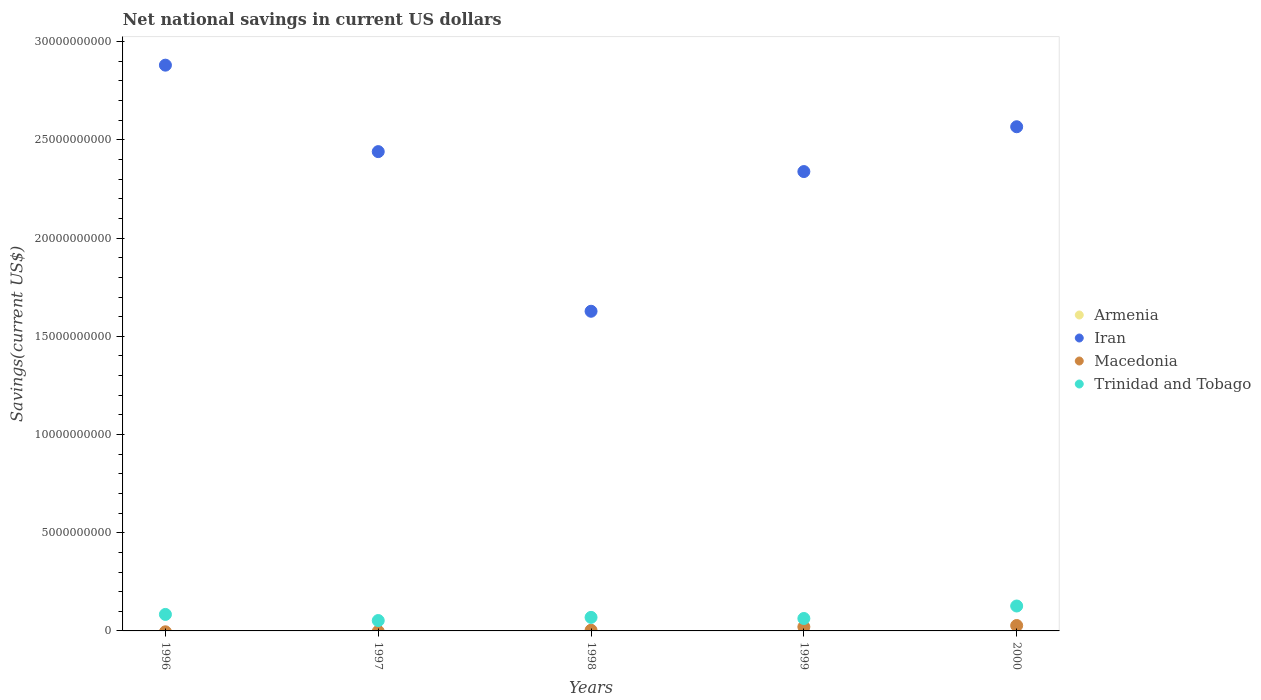How many different coloured dotlines are there?
Give a very brief answer. 3. What is the net national savings in Armenia in 1997?
Offer a terse response. 0. Across all years, what is the maximum net national savings in Trinidad and Tobago?
Your answer should be compact. 1.27e+09. Across all years, what is the minimum net national savings in Trinidad and Tobago?
Offer a terse response. 5.29e+08. What is the total net national savings in Macedonia in the graph?
Provide a succinct answer. 5.16e+08. What is the difference between the net national savings in Iran in 1997 and that in 1998?
Your answer should be very brief. 8.13e+09. What is the difference between the net national savings in Macedonia in 1998 and the net national savings in Iran in 2000?
Keep it short and to the point. -2.56e+1. What is the average net national savings in Macedonia per year?
Provide a short and direct response. 1.03e+08. In the year 2000, what is the difference between the net national savings in Iran and net national savings in Trinidad and Tobago?
Offer a very short reply. 2.44e+1. What is the ratio of the net national savings in Iran in 1996 to that in 2000?
Keep it short and to the point. 1.12. Is the net national savings in Iran in 1996 less than that in 2000?
Keep it short and to the point. No. Is the difference between the net national savings in Iran in 1996 and 1997 greater than the difference between the net national savings in Trinidad and Tobago in 1996 and 1997?
Provide a short and direct response. Yes. What is the difference between the highest and the second highest net national savings in Iran?
Offer a very short reply. 3.14e+09. What is the difference between the highest and the lowest net national savings in Trinidad and Tobago?
Provide a succinct answer. 7.40e+08. In how many years, is the net national savings in Macedonia greater than the average net national savings in Macedonia taken over all years?
Provide a short and direct response. 2. Is the sum of the net national savings in Trinidad and Tobago in 1999 and 2000 greater than the maximum net national savings in Iran across all years?
Give a very brief answer. No. How many years are there in the graph?
Keep it short and to the point. 5. What is the difference between two consecutive major ticks on the Y-axis?
Provide a succinct answer. 5.00e+09. Does the graph contain any zero values?
Your response must be concise. Yes. Does the graph contain grids?
Offer a terse response. No. Where does the legend appear in the graph?
Offer a very short reply. Center right. How are the legend labels stacked?
Keep it short and to the point. Vertical. What is the title of the graph?
Provide a succinct answer. Net national savings in current US dollars. What is the label or title of the Y-axis?
Provide a succinct answer. Savings(current US$). What is the Savings(current US$) of Armenia in 1996?
Your response must be concise. 0. What is the Savings(current US$) of Iran in 1996?
Your response must be concise. 2.88e+1. What is the Savings(current US$) in Macedonia in 1996?
Provide a short and direct response. 0. What is the Savings(current US$) in Trinidad and Tobago in 1996?
Your answer should be very brief. 8.40e+08. What is the Savings(current US$) of Armenia in 1997?
Your response must be concise. 0. What is the Savings(current US$) of Iran in 1997?
Give a very brief answer. 2.44e+1. What is the Savings(current US$) of Macedonia in 1997?
Offer a very short reply. 0. What is the Savings(current US$) in Trinidad and Tobago in 1997?
Provide a succinct answer. 5.29e+08. What is the Savings(current US$) in Armenia in 1998?
Offer a terse response. 0. What is the Savings(current US$) in Iran in 1998?
Give a very brief answer. 1.63e+1. What is the Savings(current US$) of Macedonia in 1998?
Give a very brief answer. 3.56e+07. What is the Savings(current US$) in Trinidad and Tobago in 1998?
Ensure brevity in your answer.  6.90e+08. What is the Savings(current US$) of Iran in 1999?
Make the answer very short. 2.34e+1. What is the Savings(current US$) in Macedonia in 1999?
Make the answer very short. 2.06e+08. What is the Savings(current US$) in Trinidad and Tobago in 1999?
Provide a short and direct response. 6.33e+08. What is the Savings(current US$) in Armenia in 2000?
Ensure brevity in your answer.  0. What is the Savings(current US$) in Iran in 2000?
Your answer should be very brief. 2.57e+1. What is the Savings(current US$) in Macedonia in 2000?
Provide a short and direct response. 2.75e+08. What is the Savings(current US$) of Trinidad and Tobago in 2000?
Keep it short and to the point. 1.27e+09. Across all years, what is the maximum Savings(current US$) of Iran?
Your response must be concise. 2.88e+1. Across all years, what is the maximum Savings(current US$) in Macedonia?
Your answer should be compact. 2.75e+08. Across all years, what is the maximum Savings(current US$) of Trinidad and Tobago?
Provide a short and direct response. 1.27e+09. Across all years, what is the minimum Savings(current US$) of Iran?
Keep it short and to the point. 1.63e+1. Across all years, what is the minimum Savings(current US$) of Macedonia?
Give a very brief answer. 0. Across all years, what is the minimum Savings(current US$) in Trinidad and Tobago?
Offer a very short reply. 5.29e+08. What is the total Savings(current US$) of Armenia in the graph?
Provide a succinct answer. 0. What is the total Savings(current US$) in Iran in the graph?
Provide a short and direct response. 1.19e+11. What is the total Savings(current US$) in Macedonia in the graph?
Ensure brevity in your answer.  5.16e+08. What is the total Savings(current US$) of Trinidad and Tobago in the graph?
Provide a succinct answer. 3.96e+09. What is the difference between the Savings(current US$) in Iran in 1996 and that in 1997?
Make the answer very short. 4.40e+09. What is the difference between the Savings(current US$) in Trinidad and Tobago in 1996 and that in 1997?
Give a very brief answer. 3.11e+08. What is the difference between the Savings(current US$) of Iran in 1996 and that in 1998?
Your answer should be very brief. 1.25e+1. What is the difference between the Savings(current US$) in Trinidad and Tobago in 1996 and that in 1998?
Give a very brief answer. 1.50e+08. What is the difference between the Savings(current US$) of Iran in 1996 and that in 1999?
Offer a terse response. 5.42e+09. What is the difference between the Savings(current US$) of Trinidad and Tobago in 1996 and that in 1999?
Your answer should be compact. 2.07e+08. What is the difference between the Savings(current US$) in Iran in 1996 and that in 2000?
Provide a succinct answer. 3.14e+09. What is the difference between the Savings(current US$) of Trinidad and Tobago in 1996 and that in 2000?
Your response must be concise. -4.29e+08. What is the difference between the Savings(current US$) in Iran in 1997 and that in 1998?
Provide a succinct answer. 8.13e+09. What is the difference between the Savings(current US$) of Trinidad and Tobago in 1997 and that in 1998?
Make the answer very short. -1.61e+08. What is the difference between the Savings(current US$) in Iran in 1997 and that in 1999?
Keep it short and to the point. 1.02e+09. What is the difference between the Savings(current US$) of Trinidad and Tobago in 1997 and that in 1999?
Your response must be concise. -1.05e+08. What is the difference between the Savings(current US$) in Iran in 1997 and that in 2000?
Offer a very short reply. -1.27e+09. What is the difference between the Savings(current US$) in Trinidad and Tobago in 1997 and that in 2000?
Your answer should be very brief. -7.40e+08. What is the difference between the Savings(current US$) of Iran in 1998 and that in 1999?
Ensure brevity in your answer.  -7.11e+09. What is the difference between the Savings(current US$) in Macedonia in 1998 and that in 1999?
Keep it short and to the point. -1.70e+08. What is the difference between the Savings(current US$) in Trinidad and Tobago in 1998 and that in 1999?
Give a very brief answer. 5.64e+07. What is the difference between the Savings(current US$) of Iran in 1998 and that in 2000?
Your response must be concise. -9.39e+09. What is the difference between the Savings(current US$) of Macedonia in 1998 and that in 2000?
Make the answer very short. -2.39e+08. What is the difference between the Savings(current US$) in Trinidad and Tobago in 1998 and that in 2000?
Offer a very short reply. -5.79e+08. What is the difference between the Savings(current US$) of Iran in 1999 and that in 2000?
Offer a terse response. -2.28e+09. What is the difference between the Savings(current US$) of Macedonia in 1999 and that in 2000?
Make the answer very short. -6.90e+07. What is the difference between the Savings(current US$) of Trinidad and Tobago in 1999 and that in 2000?
Keep it short and to the point. -6.36e+08. What is the difference between the Savings(current US$) in Iran in 1996 and the Savings(current US$) in Trinidad and Tobago in 1997?
Offer a terse response. 2.83e+1. What is the difference between the Savings(current US$) in Iran in 1996 and the Savings(current US$) in Macedonia in 1998?
Make the answer very short. 2.88e+1. What is the difference between the Savings(current US$) in Iran in 1996 and the Savings(current US$) in Trinidad and Tobago in 1998?
Ensure brevity in your answer.  2.81e+1. What is the difference between the Savings(current US$) of Iran in 1996 and the Savings(current US$) of Macedonia in 1999?
Give a very brief answer. 2.86e+1. What is the difference between the Savings(current US$) of Iran in 1996 and the Savings(current US$) of Trinidad and Tobago in 1999?
Your answer should be very brief. 2.82e+1. What is the difference between the Savings(current US$) of Iran in 1996 and the Savings(current US$) of Macedonia in 2000?
Provide a succinct answer. 2.85e+1. What is the difference between the Savings(current US$) of Iran in 1996 and the Savings(current US$) of Trinidad and Tobago in 2000?
Your answer should be very brief. 2.75e+1. What is the difference between the Savings(current US$) of Iran in 1997 and the Savings(current US$) of Macedonia in 1998?
Your answer should be very brief. 2.44e+1. What is the difference between the Savings(current US$) of Iran in 1997 and the Savings(current US$) of Trinidad and Tobago in 1998?
Make the answer very short. 2.37e+1. What is the difference between the Savings(current US$) of Iran in 1997 and the Savings(current US$) of Macedonia in 1999?
Provide a short and direct response. 2.42e+1. What is the difference between the Savings(current US$) in Iran in 1997 and the Savings(current US$) in Trinidad and Tobago in 1999?
Make the answer very short. 2.38e+1. What is the difference between the Savings(current US$) in Iran in 1997 and the Savings(current US$) in Macedonia in 2000?
Provide a short and direct response. 2.41e+1. What is the difference between the Savings(current US$) in Iran in 1997 and the Savings(current US$) in Trinidad and Tobago in 2000?
Make the answer very short. 2.31e+1. What is the difference between the Savings(current US$) of Iran in 1998 and the Savings(current US$) of Macedonia in 1999?
Provide a succinct answer. 1.61e+1. What is the difference between the Savings(current US$) in Iran in 1998 and the Savings(current US$) in Trinidad and Tobago in 1999?
Ensure brevity in your answer.  1.56e+1. What is the difference between the Savings(current US$) in Macedonia in 1998 and the Savings(current US$) in Trinidad and Tobago in 1999?
Ensure brevity in your answer.  -5.98e+08. What is the difference between the Savings(current US$) of Iran in 1998 and the Savings(current US$) of Macedonia in 2000?
Provide a short and direct response. 1.60e+1. What is the difference between the Savings(current US$) of Iran in 1998 and the Savings(current US$) of Trinidad and Tobago in 2000?
Offer a terse response. 1.50e+1. What is the difference between the Savings(current US$) in Macedonia in 1998 and the Savings(current US$) in Trinidad and Tobago in 2000?
Keep it short and to the point. -1.23e+09. What is the difference between the Savings(current US$) in Iran in 1999 and the Savings(current US$) in Macedonia in 2000?
Offer a terse response. 2.31e+1. What is the difference between the Savings(current US$) of Iran in 1999 and the Savings(current US$) of Trinidad and Tobago in 2000?
Make the answer very short. 2.21e+1. What is the difference between the Savings(current US$) in Macedonia in 1999 and the Savings(current US$) in Trinidad and Tobago in 2000?
Keep it short and to the point. -1.06e+09. What is the average Savings(current US$) in Iran per year?
Keep it short and to the point. 2.37e+1. What is the average Savings(current US$) in Macedonia per year?
Offer a very short reply. 1.03e+08. What is the average Savings(current US$) in Trinidad and Tobago per year?
Provide a succinct answer. 7.92e+08. In the year 1996, what is the difference between the Savings(current US$) in Iran and Savings(current US$) in Trinidad and Tobago?
Make the answer very short. 2.80e+1. In the year 1997, what is the difference between the Savings(current US$) in Iran and Savings(current US$) in Trinidad and Tobago?
Give a very brief answer. 2.39e+1. In the year 1998, what is the difference between the Savings(current US$) in Iran and Savings(current US$) in Macedonia?
Your answer should be compact. 1.62e+1. In the year 1998, what is the difference between the Savings(current US$) of Iran and Savings(current US$) of Trinidad and Tobago?
Ensure brevity in your answer.  1.56e+1. In the year 1998, what is the difference between the Savings(current US$) of Macedonia and Savings(current US$) of Trinidad and Tobago?
Provide a short and direct response. -6.54e+08. In the year 1999, what is the difference between the Savings(current US$) of Iran and Savings(current US$) of Macedonia?
Provide a short and direct response. 2.32e+1. In the year 1999, what is the difference between the Savings(current US$) of Iran and Savings(current US$) of Trinidad and Tobago?
Keep it short and to the point. 2.28e+1. In the year 1999, what is the difference between the Savings(current US$) in Macedonia and Savings(current US$) in Trinidad and Tobago?
Provide a succinct answer. -4.28e+08. In the year 2000, what is the difference between the Savings(current US$) in Iran and Savings(current US$) in Macedonia?
Offer a terse response. 2.54e+1. In the year 2000, what is the difference between the Savings(current US$) of Iran and Savings(current US$) of Trinidad and Tobago?
Your answer should be very brief. 2.44e+1. In the year 2000, what is the difference between the Savings(current US$) in Macedonia and Savings(current US$) in Trinidad and Tobago?
Provide a short and direct response. -9.94e+08. What is the ratio of the Savings(current US$) of Iran in 1996 to that in 1997?
Provide a short and direct response. 1.18. What is the ratio of the Savings(current US$) of Trinidad and Tobago in 1996 to that in 1997?
Offer a terse response. 1.59. What is the ratio of the Savings(current US$) of Iran in 1996 to that in 1998?
Give a very brief answer. 1.77. What is the ratio of the Savings(current US$) of Trinidad and Tobago in 1996 to that in 1998?
Provide a short and direct response. 1.22. What is the ratio of the Savings(current US$) of Iran in 1996 to that in 1999?
Offer a terse response. 1.23. What is the ratio of the Savings(current US$) of Trinidad and Tobago in 1996 to that in 1999?
Your response must be concise. 1.33. What is the ratio of the Savings(current US$) in Iran in 1996 to that in 2000?
Provide a succinct answer. 1.12. What is the ratio of the Savings(current US$) in Trinidad and Tobago in 1996 to that in 2000?
Your answer should be compact. 0.66. What is the ratio of the Savings(current US$) of Iran in 1997 to that in 1998?
Your answer should be very brief. 1.5. What is the ratio of the Savings(current US$) of Trinidad and Tobago in 1997 to that in 1998?
Your answer should be very brief. 0.77. What is the ratio of the Savings(current US$) in Iran in 1997 to that in 1999?
Provide a succinct answer. 1.04. What is the ratio of the Savings(current US$) of Trinidad and Tobago in 1997 to that in 1999?
Offer a terse response. 0.83. What is the ratio of the Savings(current US$) of Iran in 1997 to that in 2000?
Give a very brief answer. 0.95. What is the ratio of the Savings(current US$) of Trinidad and Tobago in 1997 to that in 2000?
Make the answer very short. 0.42. What is the ratio of the Savings(current US$) of Iran in 1998 to that in 1999?
Give a very brief answer. 0.7. What is the ratio of the Savings(current US$) of Macedonia in 1998 to that in 1999?
Give a very brief answer. 0.17. What is the ratio of the Savings(current US$) of Trinidad and Tobago in 1998 to that in 1999?
Your response must be concise. 1.09. What is the ratio of the Savings(current US$) of Iran in 1998 to that in 2000?
Give a very brief answer. 0.63. What is the ratio of the Savings(current US$) of Macedonia in 1998 to that in 2000?
Ensure brevity in your answer.  0.13. What is the ratio of the Savings(current US$) in Trinidad and Tobago in 1998 to that in 2000?
Your response must be concise. 0.54. What is the ratio of the Savings(current US$) of Iran in 1999 to that in 2000?
Make the answer very short. 0.91. What is the ratio of the Savings(current US$) of Macedonia in 1999 to that in 2000?
Keep it short and to the point. 0.75. What is the ratio of the Savings(current US$) in Trinidad and Tobago in 1999 to that in 2000?
Offer a very short reply. 0.5. What is the difference between the highest and the second highest Savings(current US$) of Iran?
Keep it short and to the point. 3.14e+09. What is the difference between the highest and the second highest Savings(current US$) of Macedonia?
Your answer should be very brief. 6.90e+07. What is the difference between the highest and the second highest Savings(current US$) in Trinidad and Tobago?
Offer a terse response. 4.29e+08. What is the difference between the highest and the lowest Savings(current US$) of Iran?
Your answer should be very brief. 1.25e+1. What is the difference between the highest and the lowest Savings(current US$) of Macedonia?
Ensure brevity in your answer.  2.75e+08. What is the difference between the highest and the lowest Savings(current US$) of Trinidad and Tobago?
Offer a very short reply. 7.40e+08. 